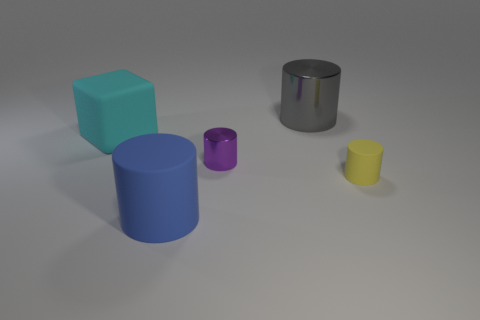Add 3 tiny green metal spheres. How many objects exist? 8 Subtract all cylinders. How many objects are left? 1 Subtract 1 gray cylinders. How many objects are left? 4 Subtract all big blue matte cylinders. Subtract all yellow cylinders. How many objects are left? 3 Add 5 big gray cylinders. How many big gray cylinders are left? 6 Add 4 cyan spheres. How many cyan spheres exist? 4 